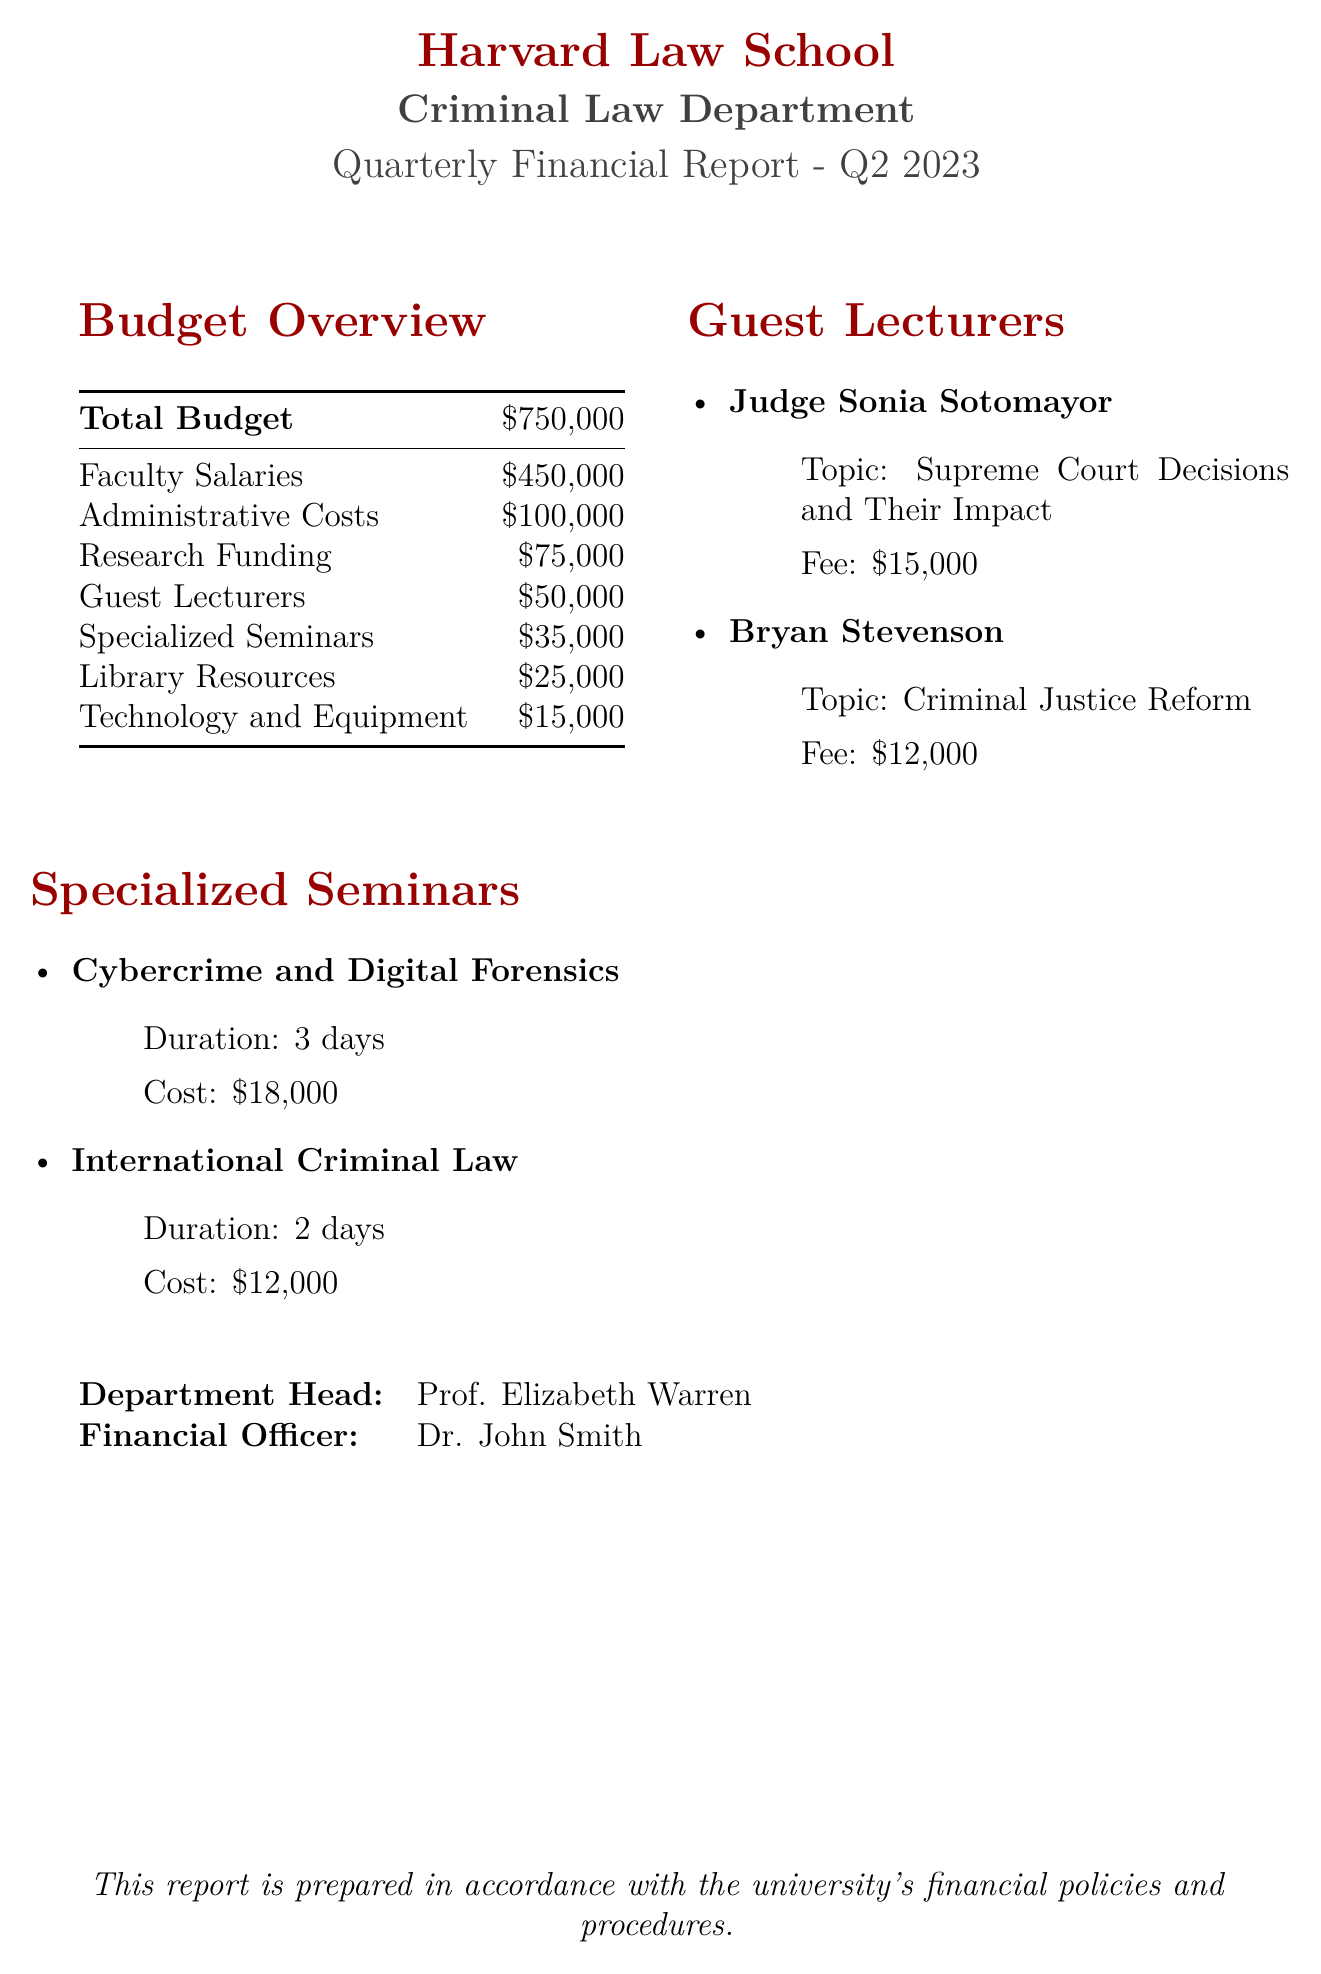What is the total budget for the Criminal Law Department? The total budget is explicitly provided in the document.
Answer: $750,000 What is the amount allocated for Guest Lecturers? The document specifies the budget category for Guest Lecturers.
Answer: $50,000 Who is the department head? The name of the department head is listed clearly in the document.
Answer: Prof. Elizabeth Warren What is the fee for Judge Sonia Sotomayor? The document provides specific fees for each guest lecturer.
Answer: $15,000 How much is allocated for Specialized Seminars? The total amount for Specialized Seminars is provided in the expenses section.
Answer: $35,000 What is the duration of the Cybercrime and Digital Forensics seminar? The document states the duration of each specialized seminar.
Answer: 3 days What is the total expense for Faculty Salaries and Administrative Costs combined? This requires basic addition of two expense categories listed in the document.
Answer: $550,000 Name one topic covered by a guest lecturer. The document lists topics associated with guest lecturers.
Answer: Supreme Court Decisions and Their Impact What is the cost of the International Criminal Law seminar? The cost for each seminar is specified in the document.
Answer: $12,000 